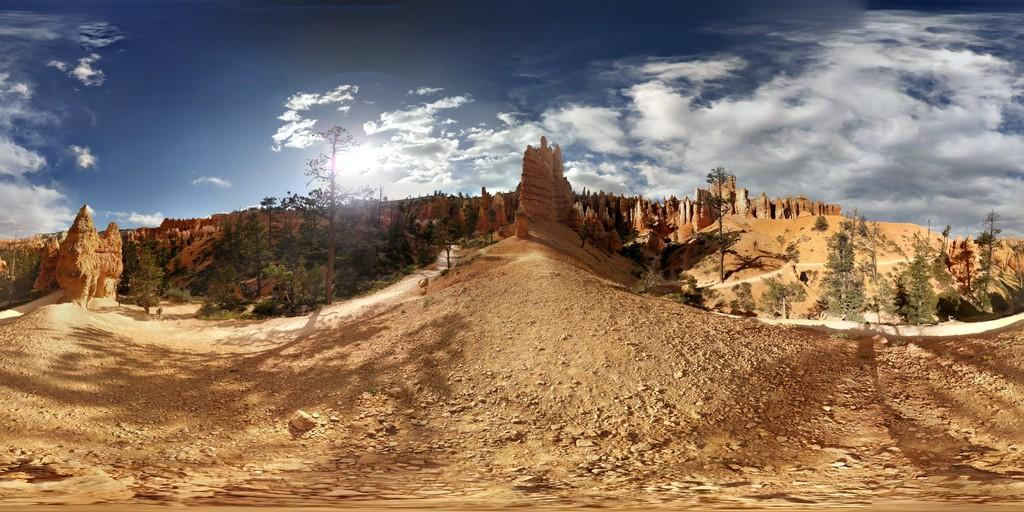What is the weather like in the image? The sky is clear and sunny with some clouds, indicating a partly sunny day. What type of vegetation can be seen in the image? There are many trees in the image. What kind of landscape feature is present in the image? There are hills in the image. Can you see any poisonous plants in the image? There is no information about the types of plants in the image, so it cannot be determined if any are poisonous. What color is the balloon in the image? There is no balloon present in the image. 